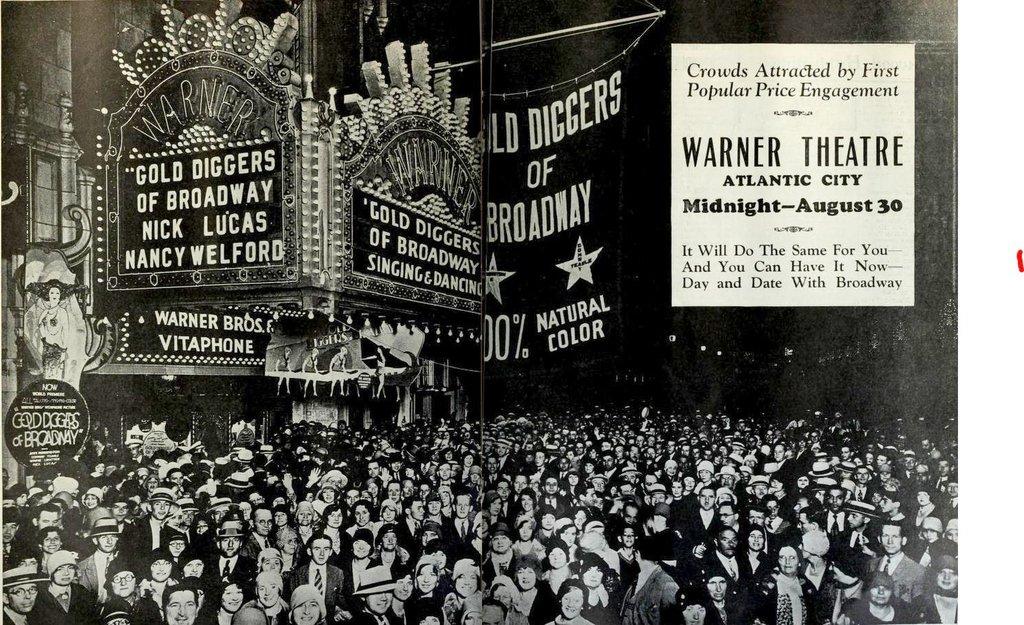Where are the gold diggers from, according to the sign?
Your answer should be very brief. Broadway. Where is the theater?
Your response must be concise. Atlantic city. 